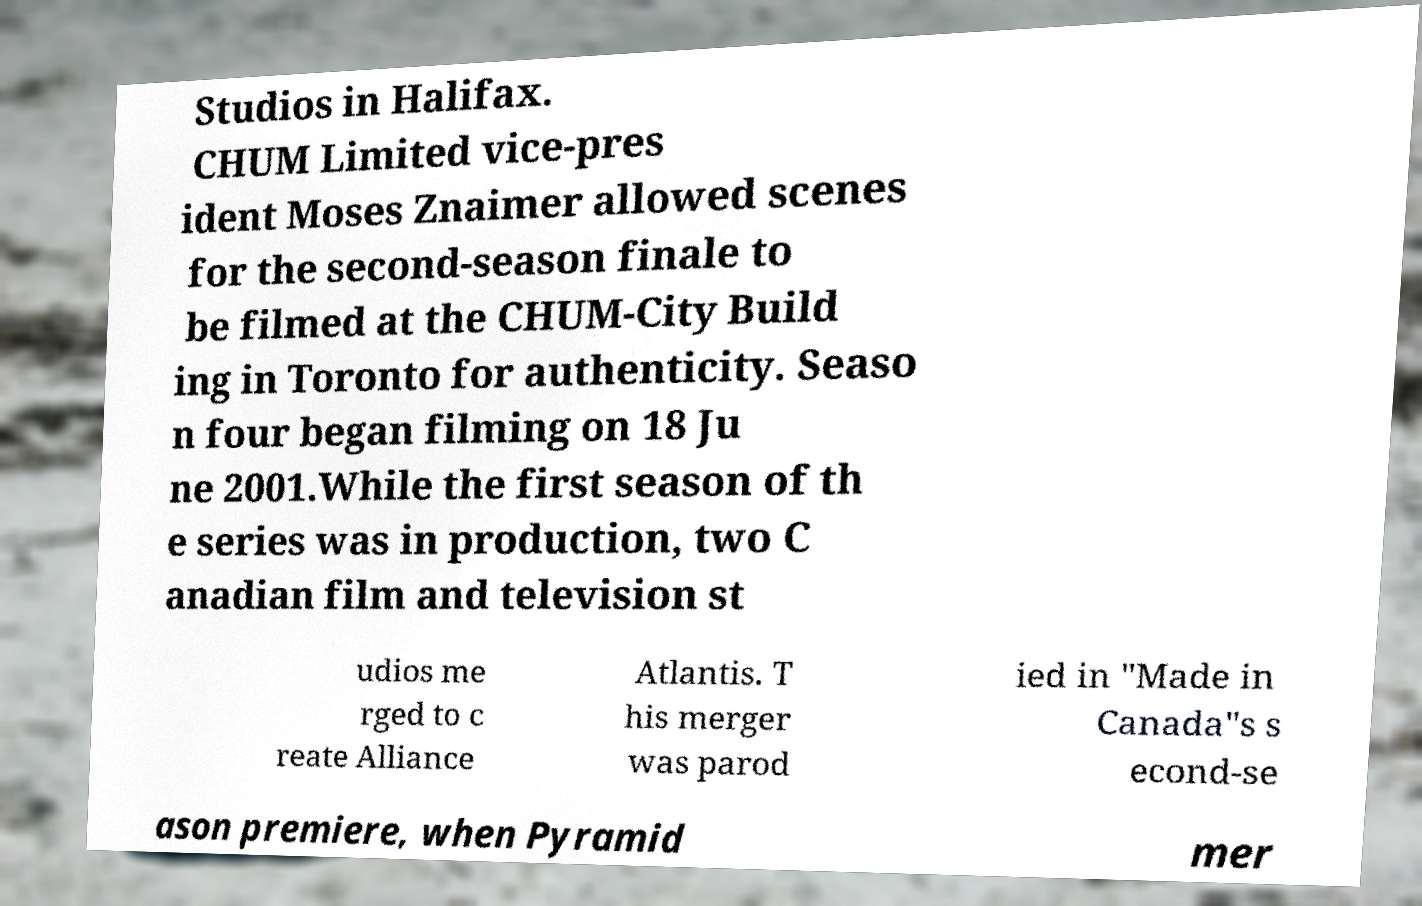Could you extract and type out the text from this image? Studios in Halifax. CHUM Limited vice-pres ident Moses Znaimer allowed scenes for the second-season finale to be filmed at the CHUM-City Build ing in Toronto for authenticity. Seaso n four began filming on 18 Ju ne 2001.While the first season of th e series was in production, two C anadian film and television st udios me rged to c reate Alliance Atlantis. T his merger was parod ied in "Made in Canada"s s econd-se ason premiere, when Pyramid mer 